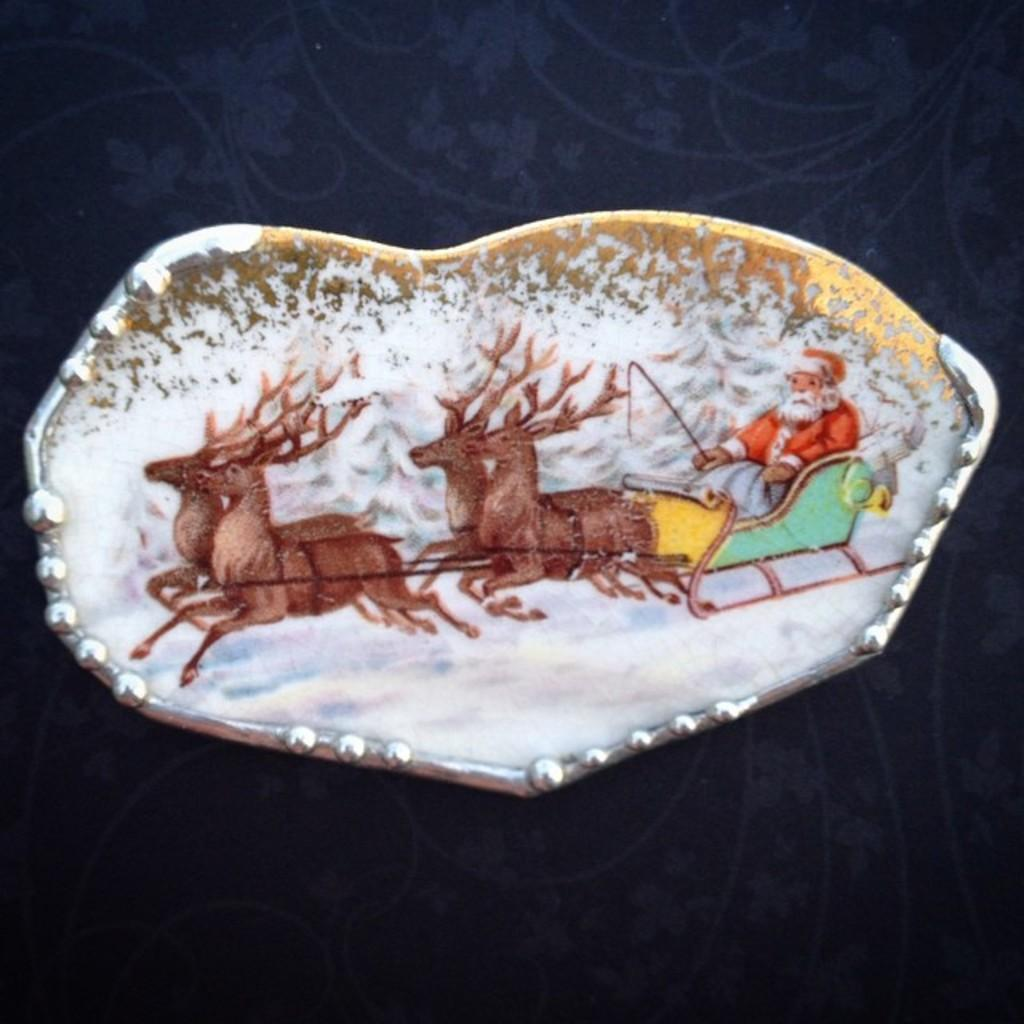What type of decorative item is in the image? The decorative item features a person riding a deer cart. Can you describe the scene depicted on the decorative item? The scene depicts a person riding a deer cart. What type of weather is shown in the image? Snow is present in the image, indicating a winter setting. What type of sofa can be seen in the image? There is no sofa present in the image. How does the person riding the deer cart say good-bye to the deer? The image does not show the person interacting with the deer or saying good-bye, as it is a decorative item. 